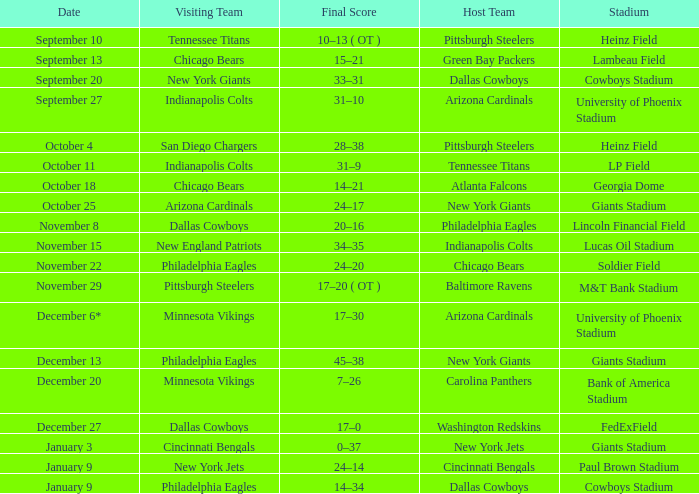What's the final count for december 27? 17–0. 